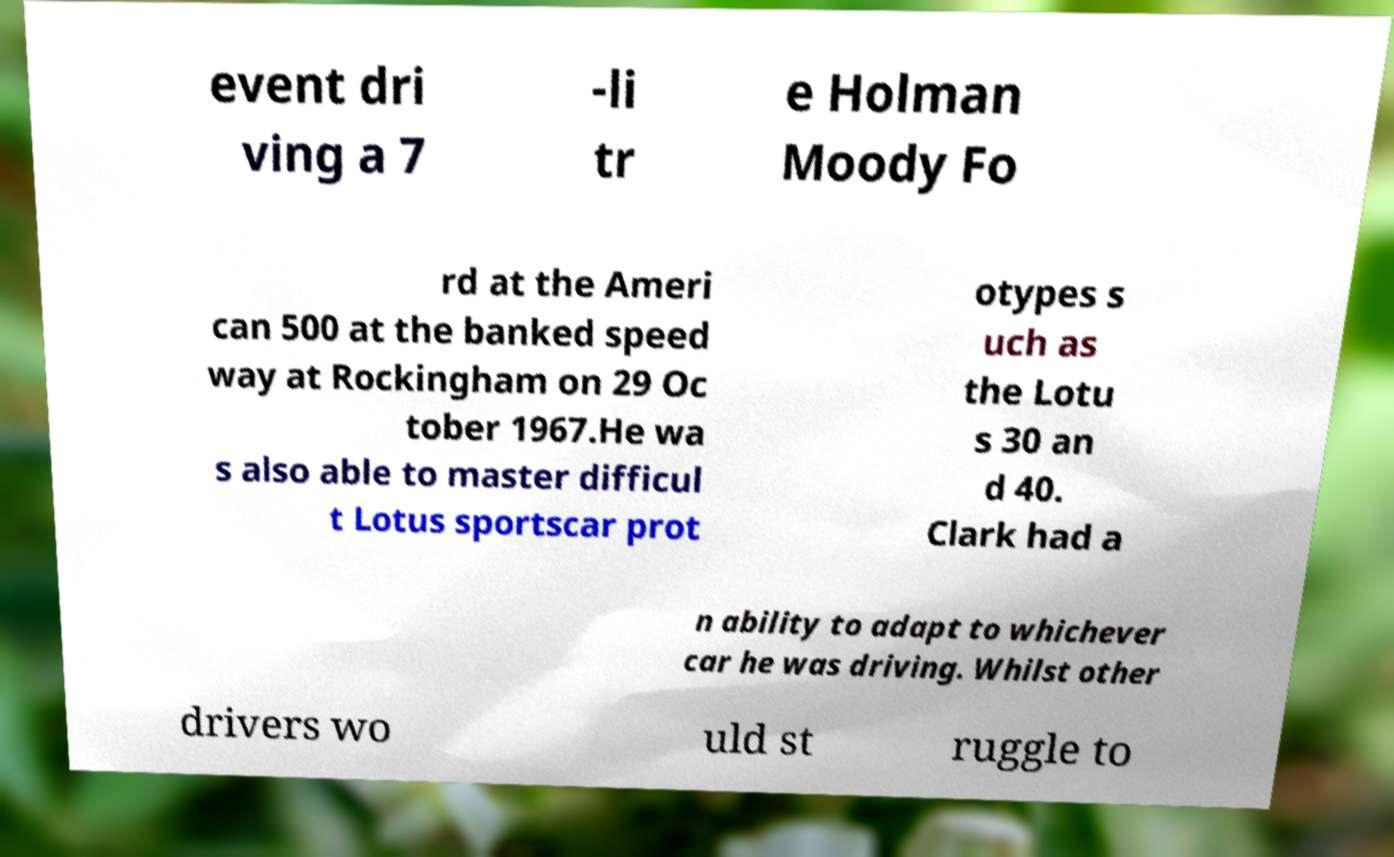Please identify and transcribe the text found in this image. event dri ving a 7 -li tr e Holman Moody Fo rd at the Ameri can 500 at the banked speed way at Rockingham on 29 Oc tober 1967.He wa s also able to master difficul t Lotus sportscar prot otypes s uch as the Lotu s 30 an d 40. Clark had a n ability to adapt to whichever car he was driving. Whilst other drivers wo uld st ruggle to 